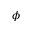Convert formula to latex. <formula><loc_0><loc_0><loc_500><loc_500>\phi</formula> 